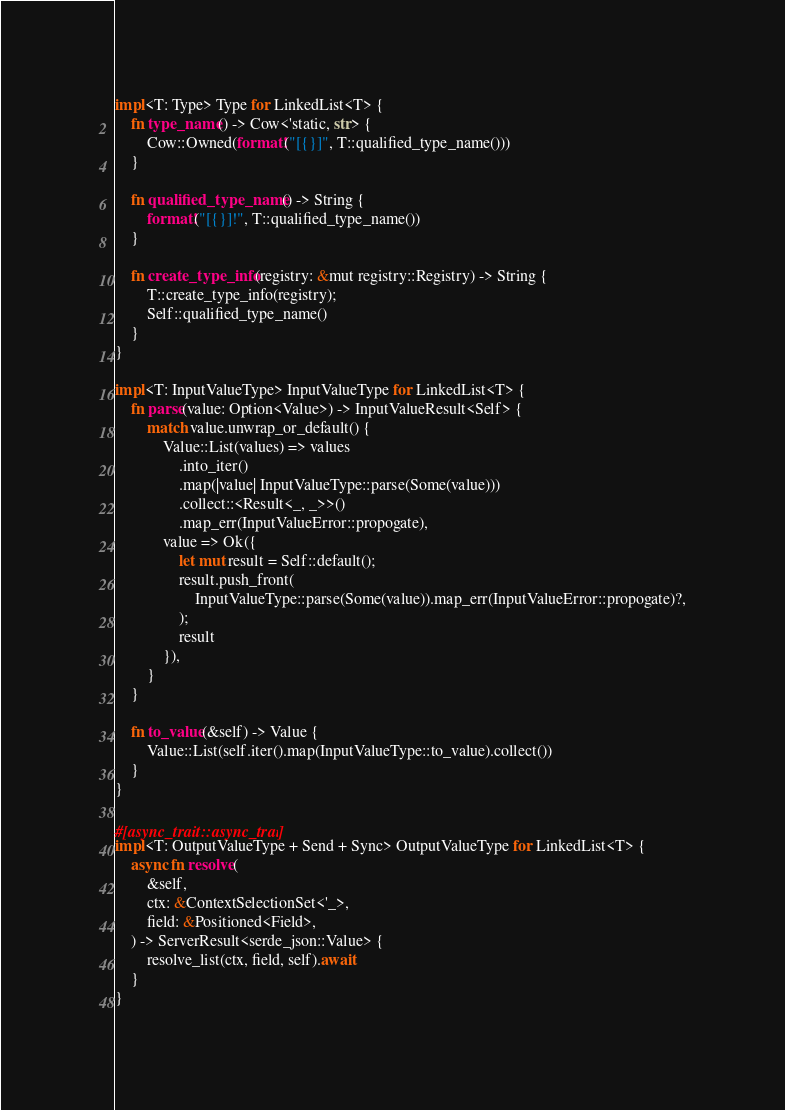<code> <loc_0><loc_0><loc_500><loc_500><_Rust_>impl<T: Type> Type for LinkedList<T> {
    fn type_name() -> Cow<'static, str> {
        Cow::Owned(format!("[{}]", T::qualified_type_name()))
    }

    fn qualified_type_name() -> String {
        format!("[{}]!", T::qualified_type_name())
    }

    fn create_type_info(registry: &mut registry::Registry) -> String {
        T::create_type_info(registry);
        Self::qualified_type_name()
    }
}

impl<T: InputValueType> InputValueType for LinkedList<T> {
    fn parse(value: Option<Value>) -> InputValueResult<Self> {
        match value.unwrap_or_default() {
            Value::List(values) => values
                .into_iter()
                .map(|value| InputValueType::parse(Some(value)))
                .collect::<Result<_, _>>()
                .map_err(InputValueError::propogate),
            value => Ok({
                let mut result = Self::default();
                result.push_front(
                    InputValueType::parse(Some(value)).map_err(InputValueError::propogate)?,
                );
                result
            }),
        }
    }

    fn to_value(&self) -> Value {
        Value::List(self.iter().map(InputValueType::to_value).collect())
    }
}

#[async_trait::async_trait]
impl<T: OutputValueType + Send + Sync> OutputValueType for LinkedList<T> {
    async fn resolve(
        &self,
        ctx: &ContextSelectionSet<'_>,
        field: &Positioned<Field>,
    ) -> ServerResult<serde_json::Value> {
        resolve_list(ctx, field, self).await
    }
}
</code> 